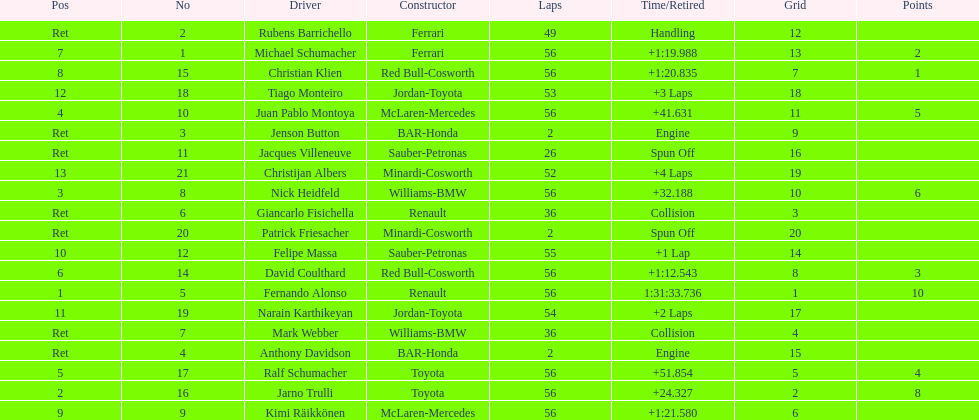How many germans finished in the top five? 2. 